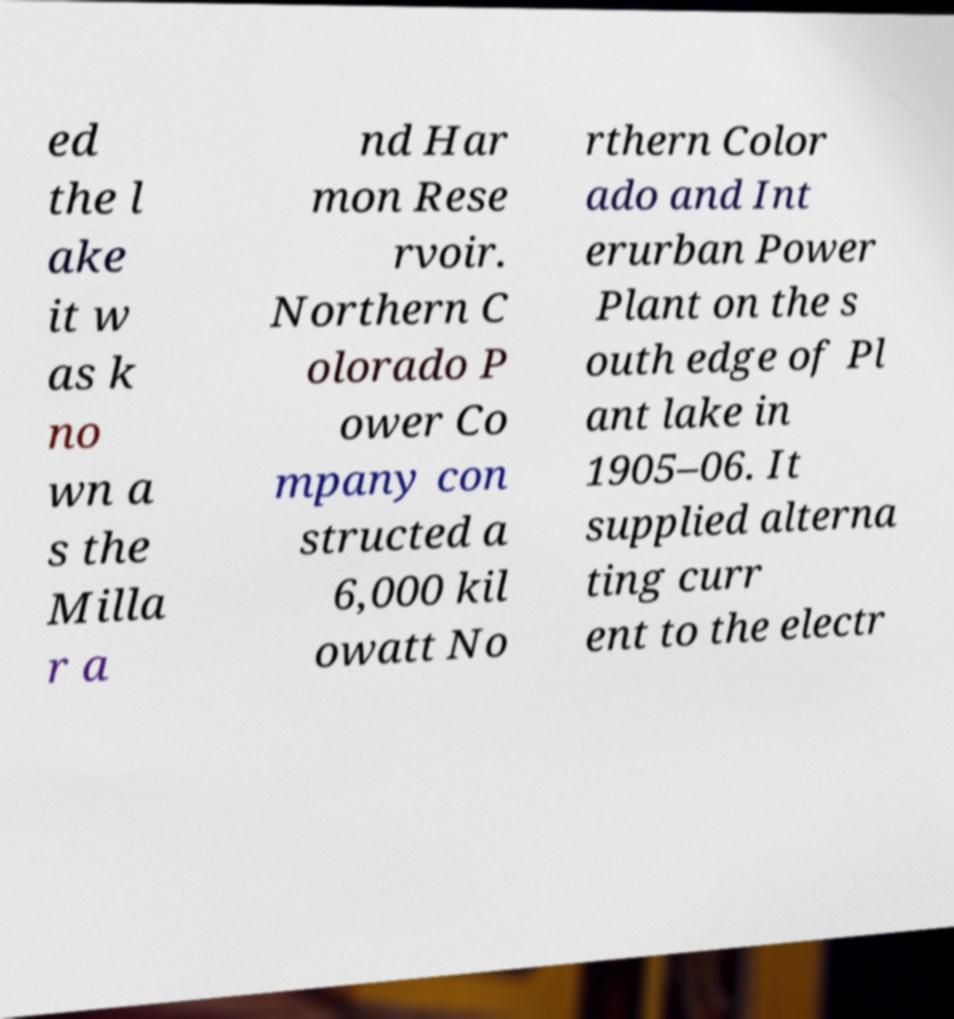Could you assist in decoding the text presented in this image and type it out clearly? ed the l ake it w as k no wn a s the Milla r a nd Har mon Rese rvoir. Northern C olorado P ower Co mpany con structed a 6,000 kil owatt No rthern Color ado and Int erurban Power Plant on the s outh edge of Pl ant lake in 1905–06. It supplied alterna ting curr ent to the electr 